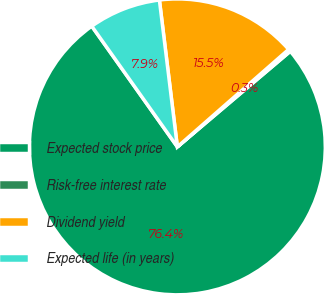<chart> <loc_0><loc_0><loc_500><loc_500><pie_chart><fcel>Expected stock price<fcel>Risk-free interest rate<fcel>Dividend yield<fcel>Expected life (in years)<nl><fcel>76.37%<fcel>0.27%<fcel>15.49%<fcel>7.88%<nl></chart> 